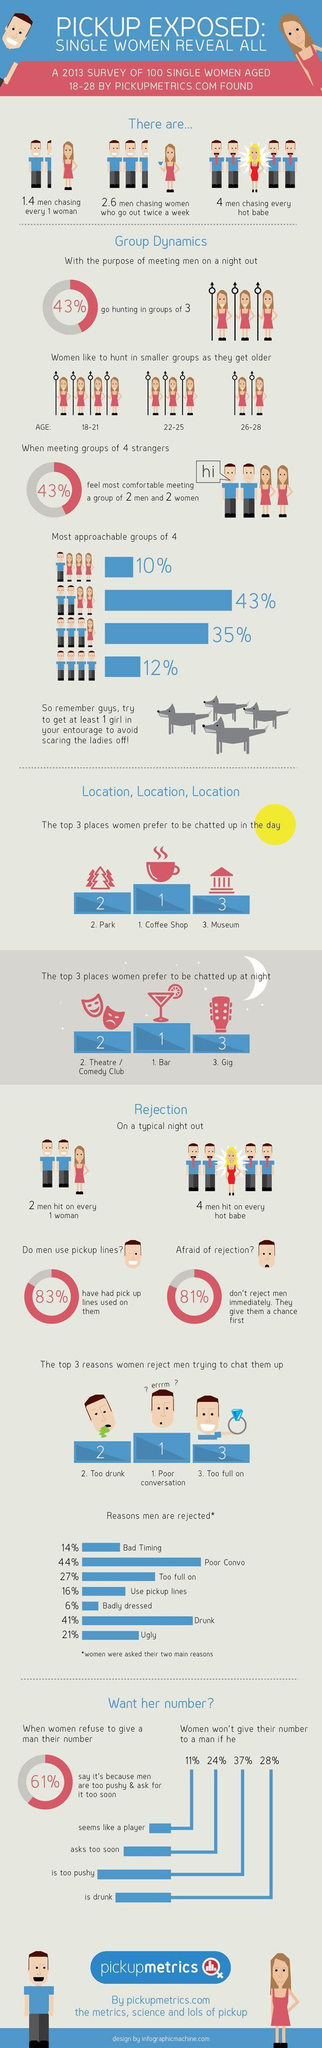How many girls are in the group while hunting for men in the age of 18-21?
Answer the question with a short phrase. 4 What percentage of men are not afraid of rejection? 19% What percentage of women don't give their number to a man if he is drunk and is too pushy, taken together? 65% What percentage of men don't use pickup lines? 17% What percentage are not comfortable meeting a group of 2 men and 2 women? 57% What percentage of women don't go out hunting in groups of 3? 57% How many girls are in the group while hunting for men in the age of 22-25? 3 What percentage of women don't give their number to a man if he seems like a player and asks too soon, taken together? 35% What percentage of drunk and ugly men are rejected by women, taken together? 62% What percentage of badly-dressed and too full-on men are rejected by women, taken together? 33% How many girls are in the group while hunting for men in the age of 26-28? 2 